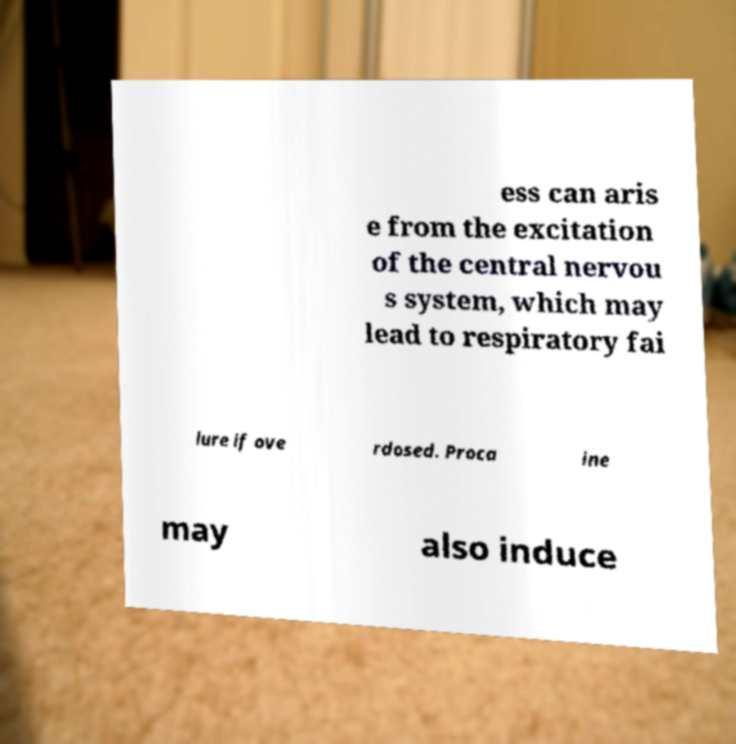For documentation purposes, I need the text within this image transcribed. Could you provide that? ess can aris e from the excitation of the central nervou s system, which may lead to respiratory fai lure if ove rdosed. Proca ine may also induce 